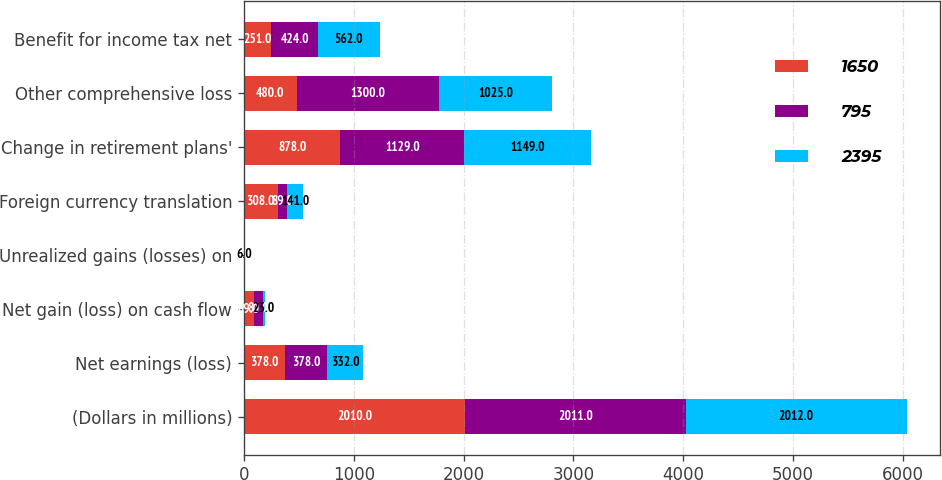Convert chart. <chart><loc_0><loc_0><loc_500><loc_500><stacked_bar_chart><ecel><fcel>(Dollars in millions)<fcel>Net earnings (loss)<fcel>Net gain (loss) on cash flow<fcel>Unrealized gains (losses) on<fcel>Foreign currency translation<fcel>Change in retirement plans'<fcel>Other comprehensive loss<fcel>Benefit for income tax net<nl><fcel>1650<fcel>2010<fcel>378<fcel>89<fcel>1<fcel>308<fcel>878<fcel>480<fcel>251<nl><fcel>795<fcel>2011<fcel>378<fcel>81<fcel>1<fcel>89<fcel>1129<fcel>1300<fcel>424<nl><fcel>2395<fcel>2012<fcel>332<fcel>23<fcel>6<fcel>141<fcel>1149<fcel>1025<fcel>562<nl></chart> 